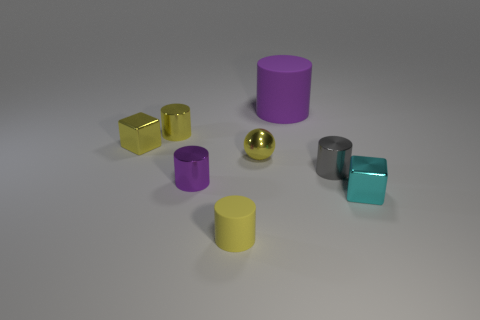Subtract all gray cylinders. How many cylinders are left? 4 Subtract all gray metal cylinders. How many cylinders are left? 4 Subtract all green cylinders. Subtract all purple blocks. How many cylinders are left? 5 Add 1 big objects. How many objects exist? 9 Subtract all blocks. How many objects are left? 6 Subtract all gray things. Subtract all small green cylinders. How many objects are left? 7 Add 2 small gray metallic cylinders. How many small gray metallic cylinders are left? 3 Add 8 gray matte spheres. How many gray matte spheres exist? 8 Subtract 0 gray spheres. How many objects are left? 8 